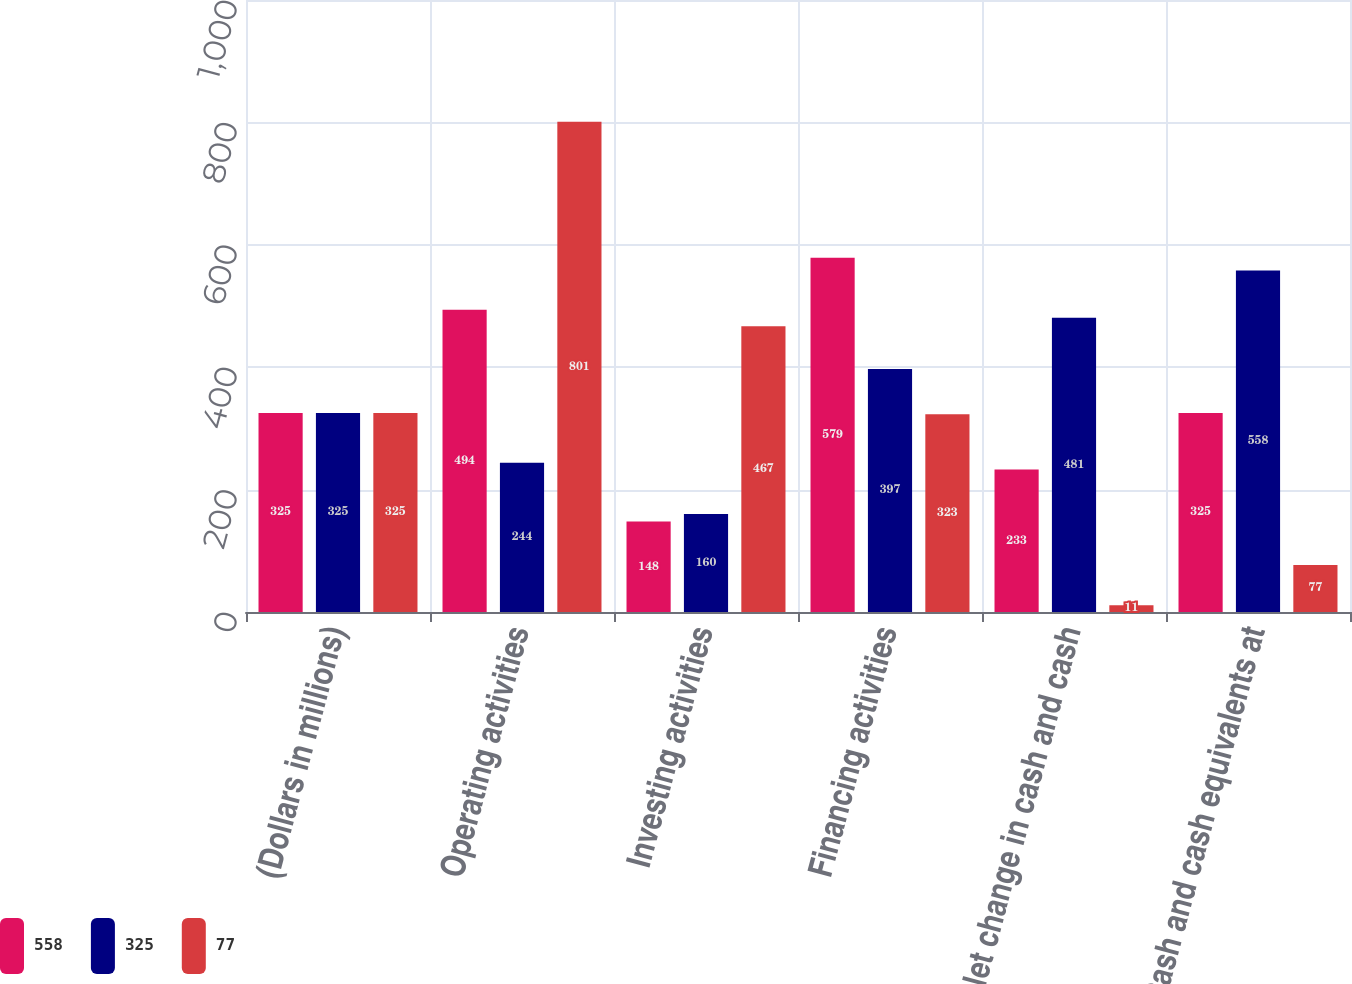Convert chart to OTSL. <chart><loc_0><loc_0><loc_500><loc_500><stacked_bar_chart><ecel><fcel>(Dollars in millions)<fcel>Operating activities<fcel>Investing activities<fcel>Financing activities<fcel>Net change in cash and cash<fcel>Cash and cash equivalents at<nl><fcel>558<fcel>325<fcel>494<fcel>148<fcel>579<fcel>233<fcel>325<nl><fcel>325<fcel>325<fcel>244<fcel>160<fcel>397<fcel>481<fcel>558<nl><fcel>77<fcel>325<fcel>801<fcel>467<fcel>323<fcel>11<fcel>77<nl></chart> 